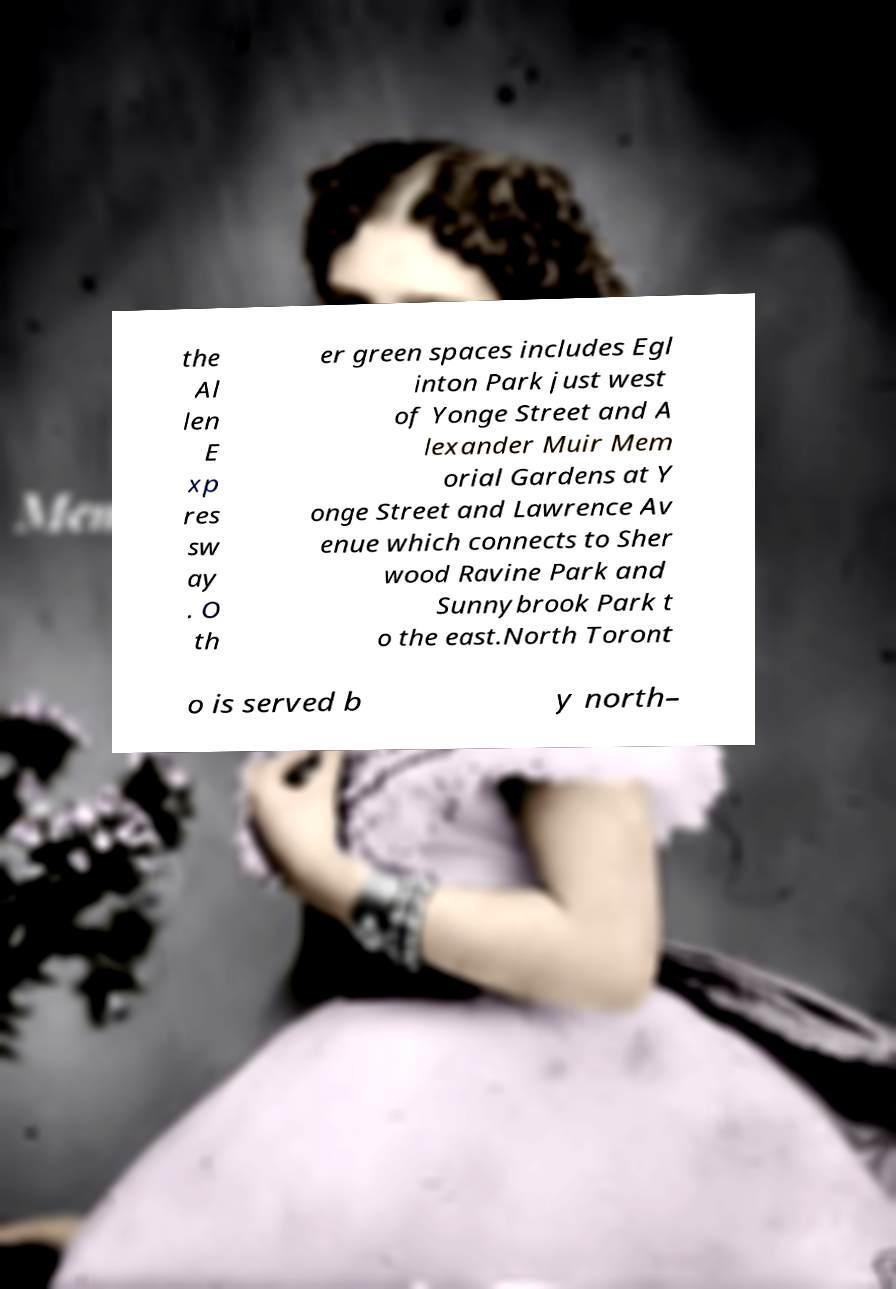Could you assist in decoding the text presented in this image and type it out clearly? the Al len E xp res sw ay . O th er green spaces includes Egl inton Park just west of Yonge Street and A lexander Muir Mem orial Gardens at Y onge Street and Lawrence Av enue which connects to Sher wood Ravine Park and Sunnybrook Park t o the east.North Toront o is served b y north– 